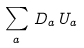<formula> <loc_0><loc_0><loc_500><loc_500>\sum _ { a } \, D _ { a } \, U _ { a }</formula> 